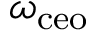Convert formula to latex. <formula><loc_0><loc_0><loc_500><loc_500>\omega _ { c e o }</formula> 